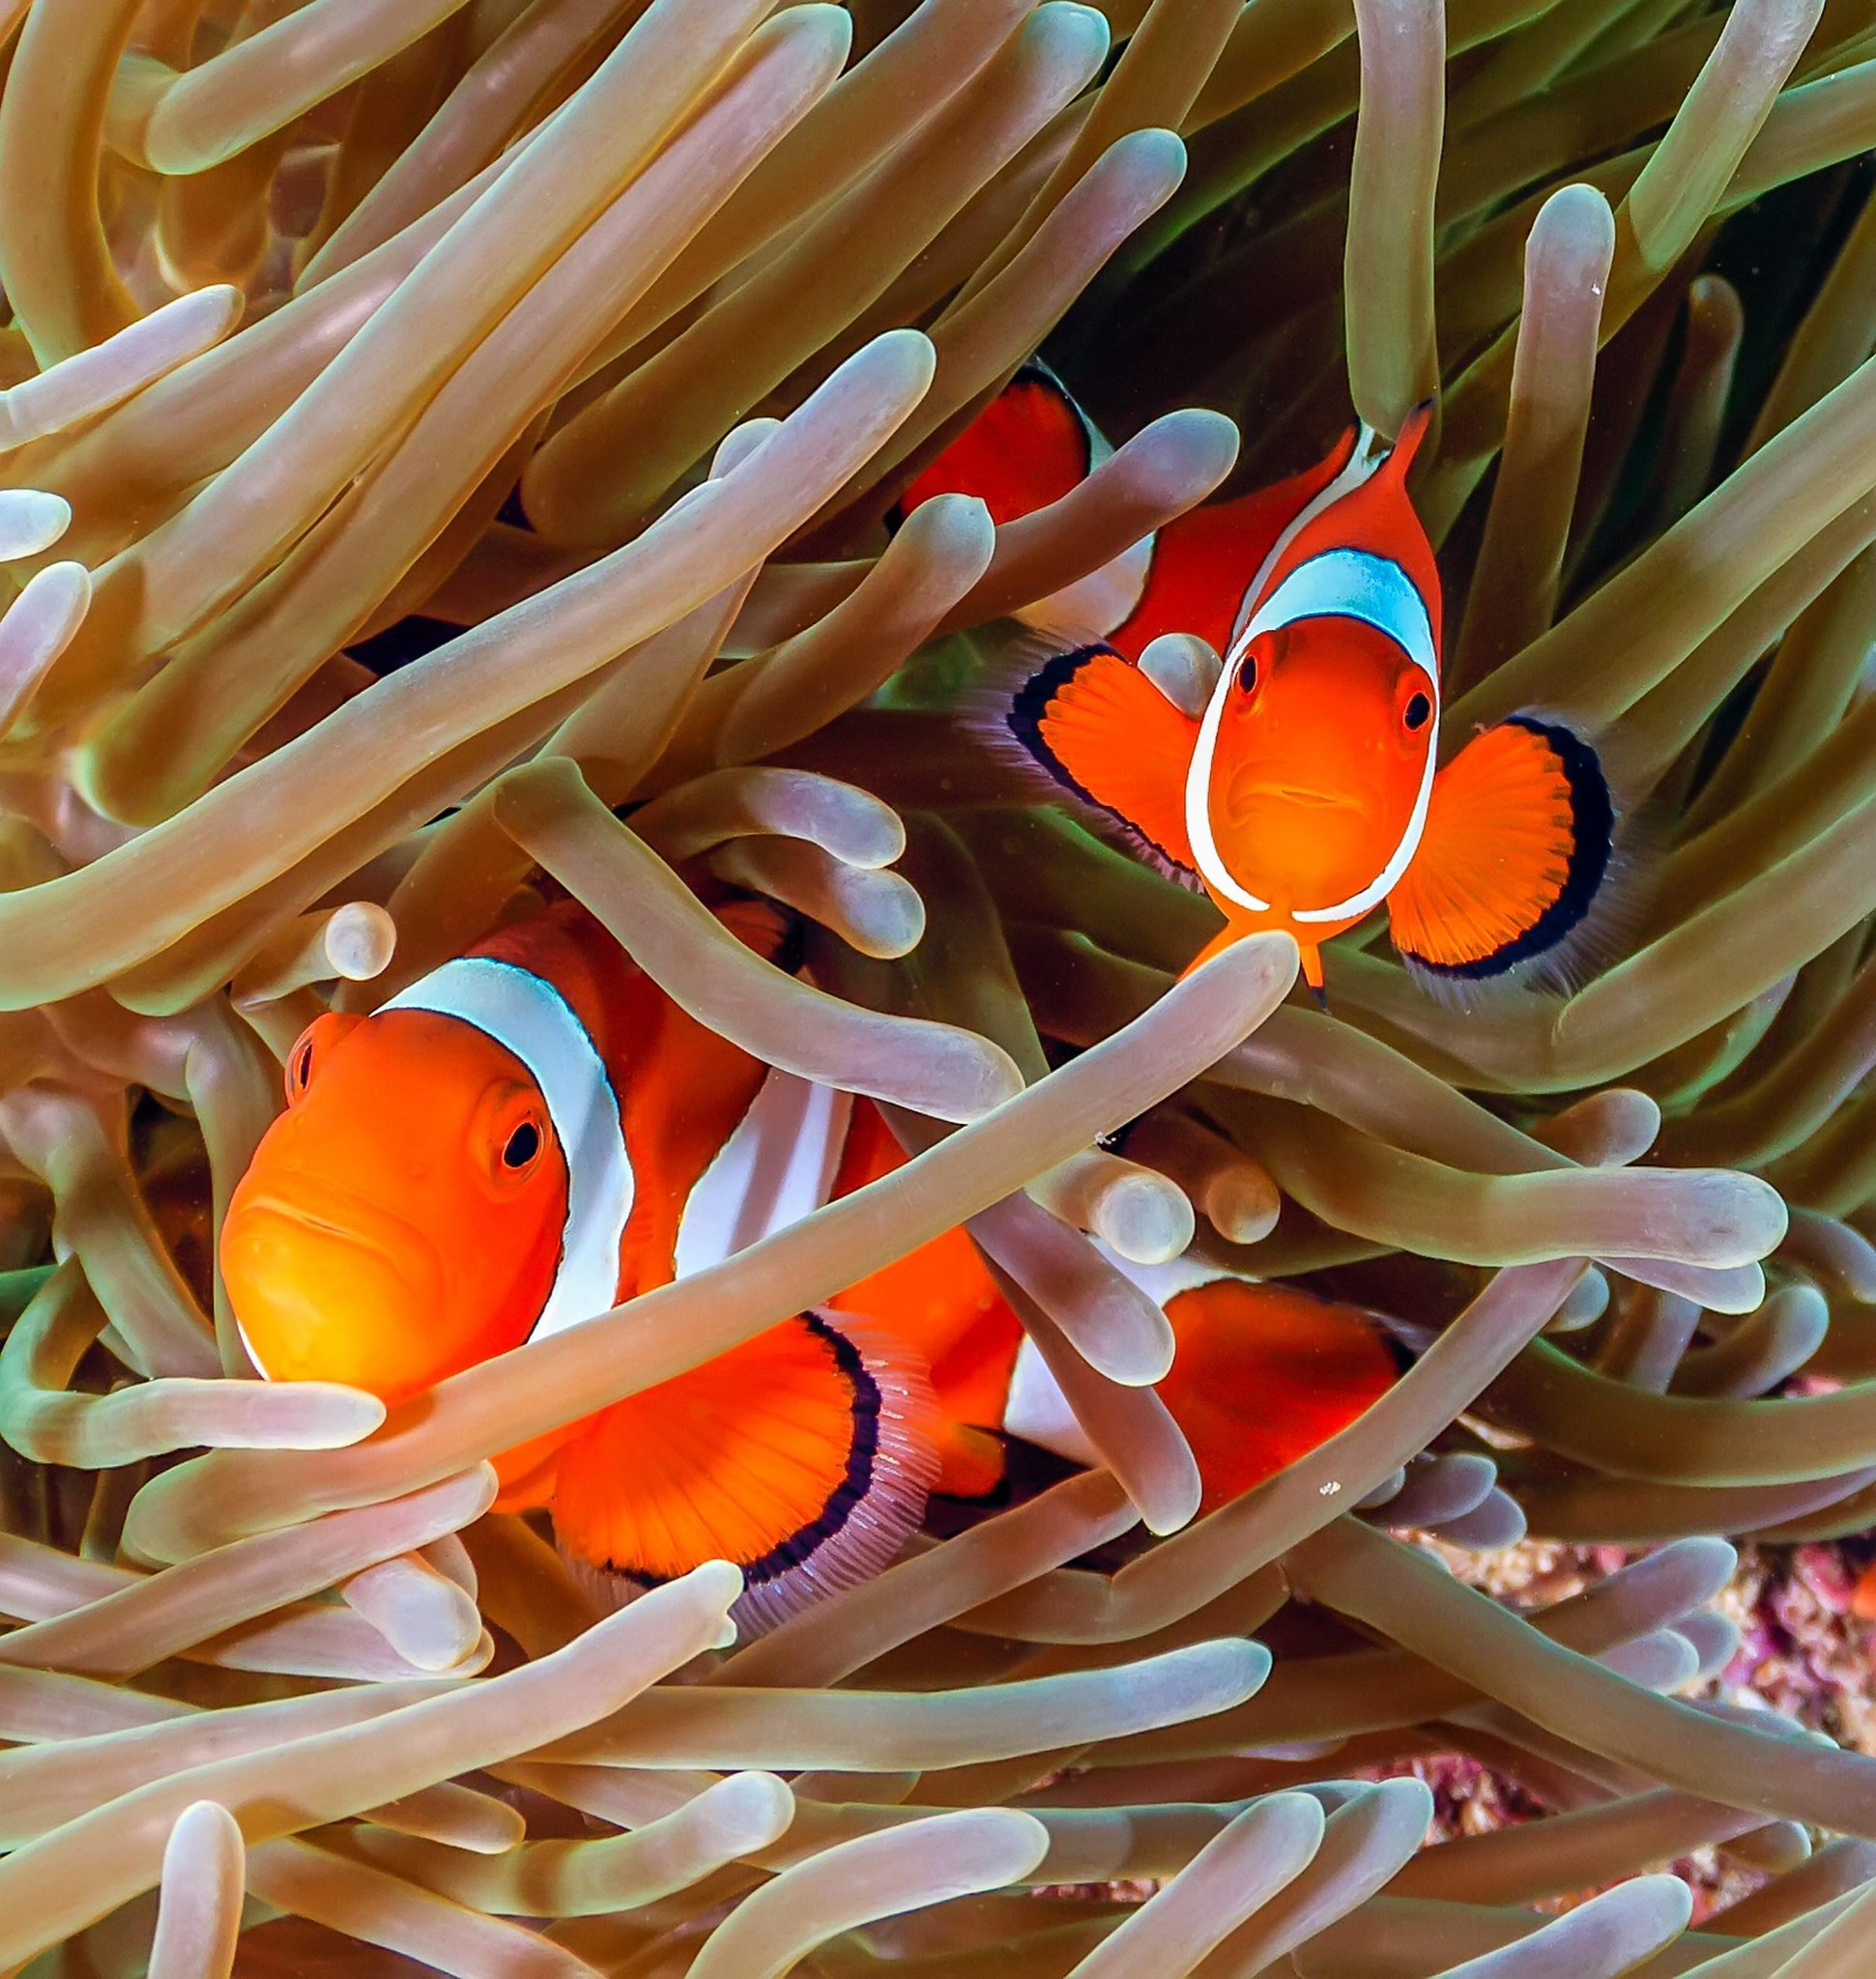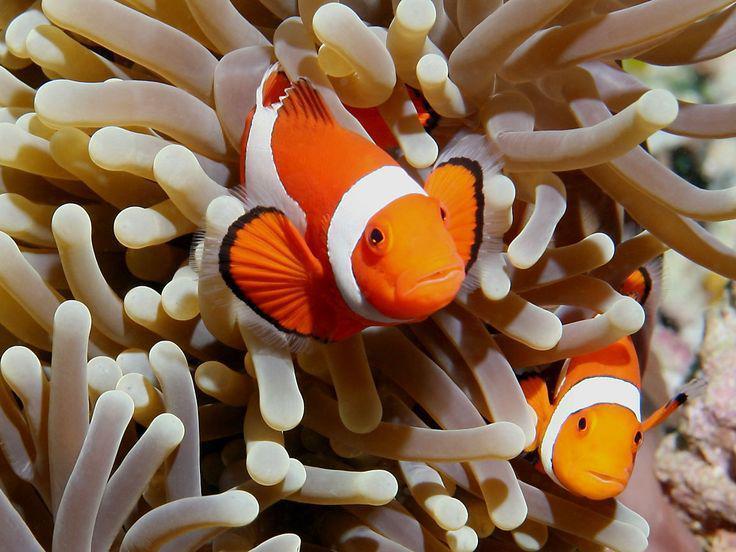The first image is the image on the left, the second image is the image on the right. Examine the images to the left and right. Is the description "Each image features no more than two orange fish in the foreground, and the fish in the left and right images are posed among anemone tendrils of the same color." accurate? Answer yes or no. Yes. The first image is the image on the left, the second image is the image on the right. Analyze the images presented: Is the assertion "In at least one image there is a single white clownfish with white, black and orange colors swimming through  the arms of corral." valid? Answer yes or no. No. 